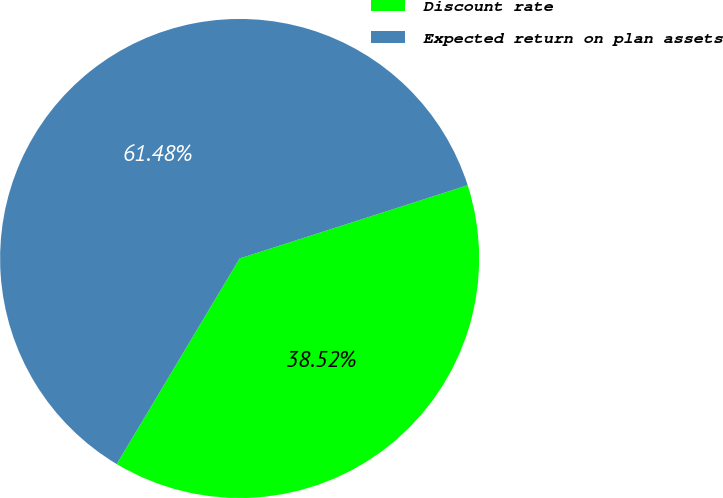<chart> <loc_0><loc_0><loc_500><loc_500><pie_chart><fcel>Discount rate<fcel>Expected return on plan assets<nl><fcel>38.52%<fcel>61.48%<nl></chart> 